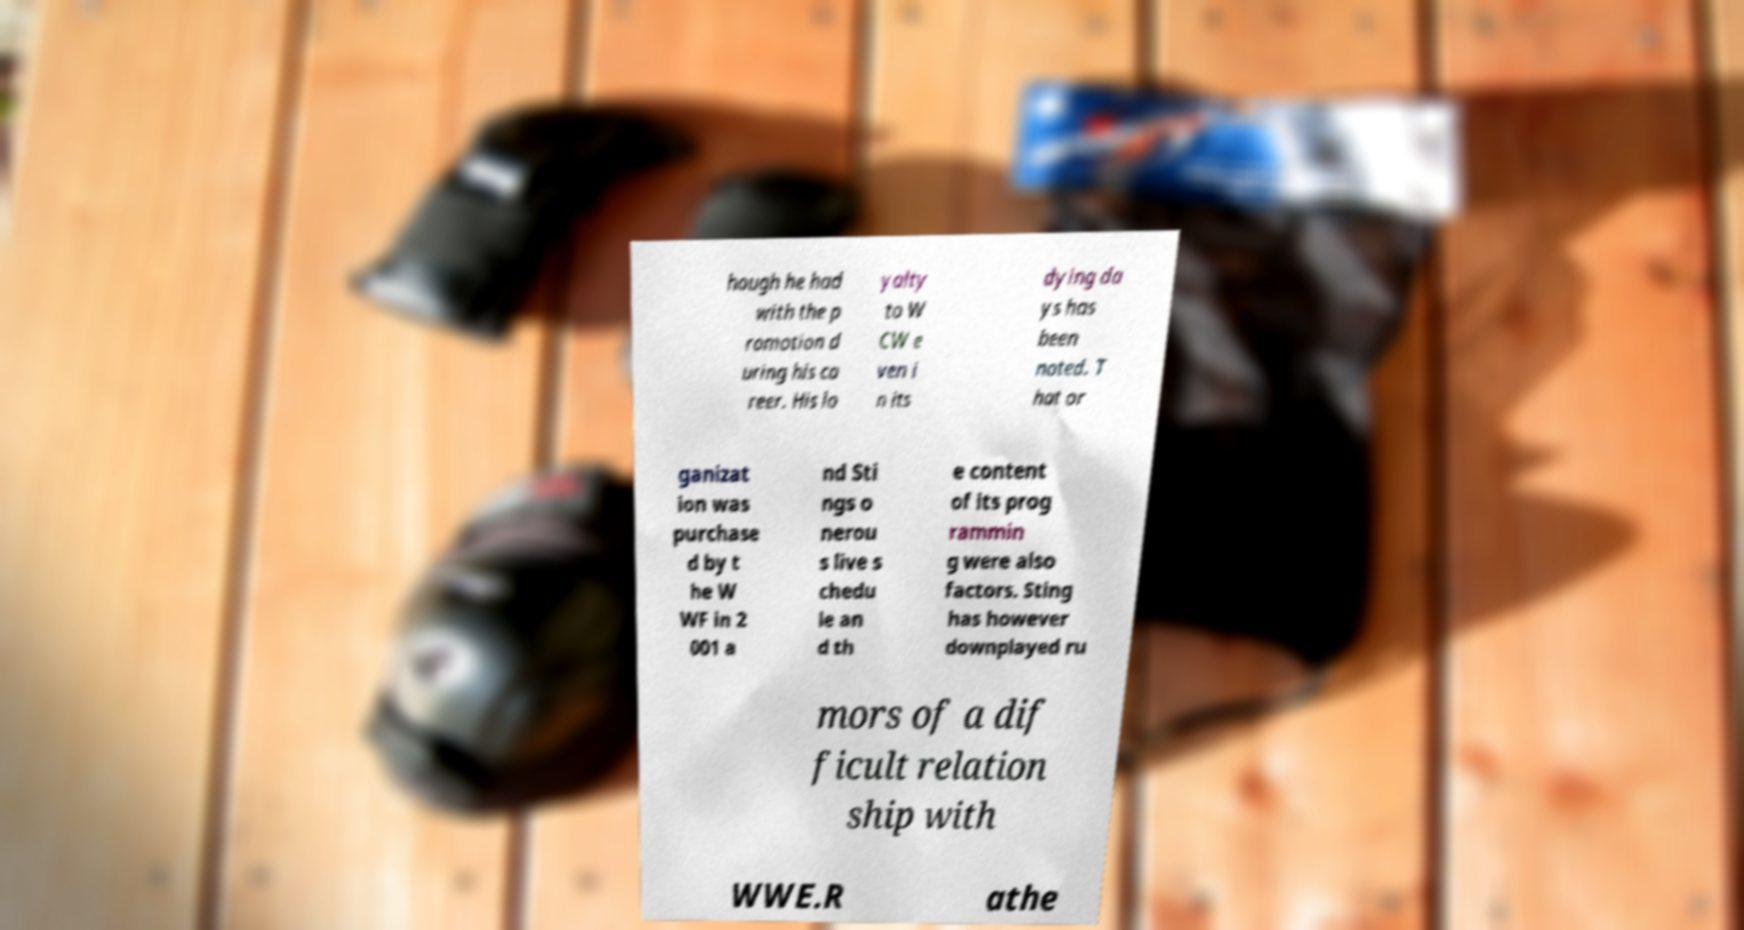I need the written content from this picture converted into text. Can you do that? hough he had with the p romotion d uring his ca reer. His lo yalty to W CW e ven i n its dying da ys has been noted. T hat or ganizat ion was purchase d by t he W WF in 2 001 a nd Sti ngs o nerou s live s chedu le an d th e content of its prog rammin g were also factors. Sting has however downplayed ru mors of a dif ficult relation ship with WWE.R athe 